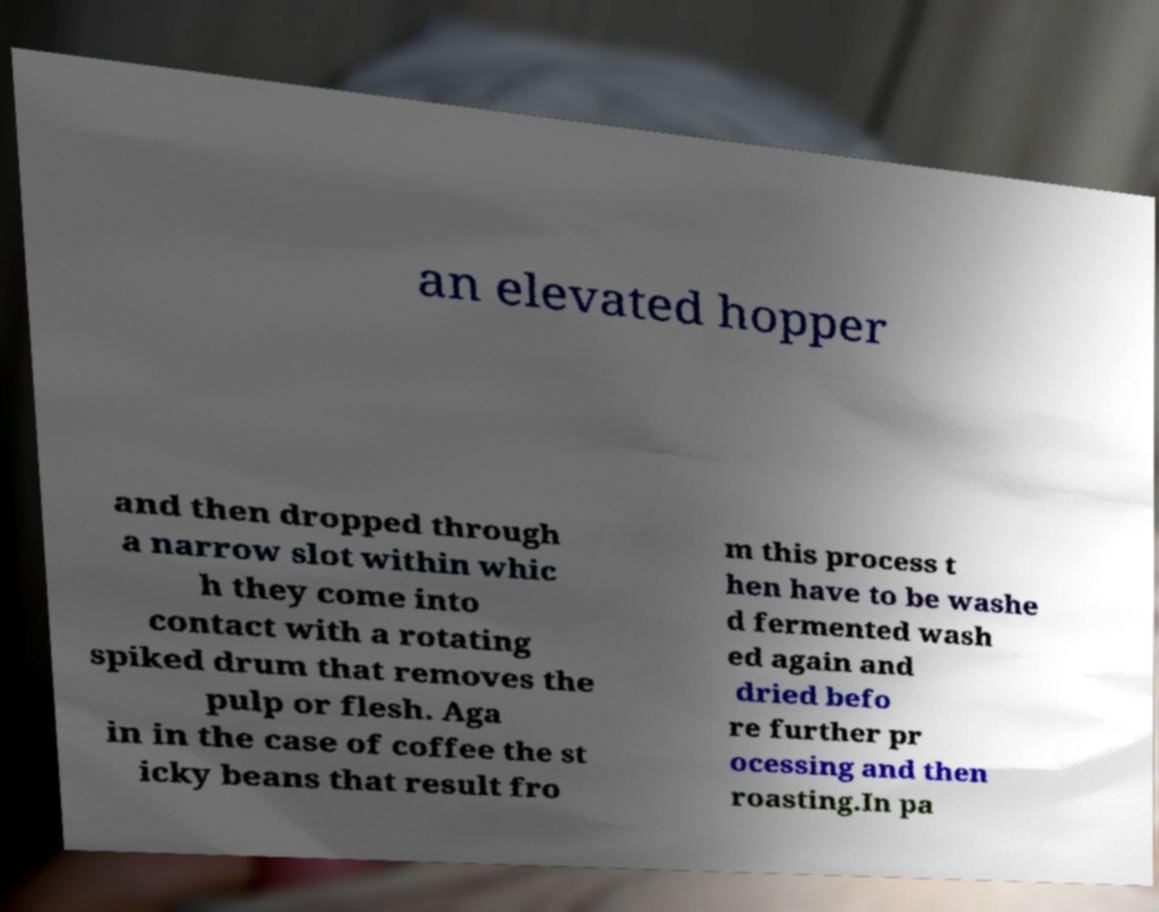I need the written content from this picture converted into text. Can you do that? an elevated hopper and then dropped through a narrow slot within whic h they come into contact with a rotating spiked drum that removes the pulp or flesh. Aga in in the case of coffee the st icky beans that result fro m this process t hen have to be washe d fermented wash ed again and dried befo re further pr ocessing and then roasting.In pa 